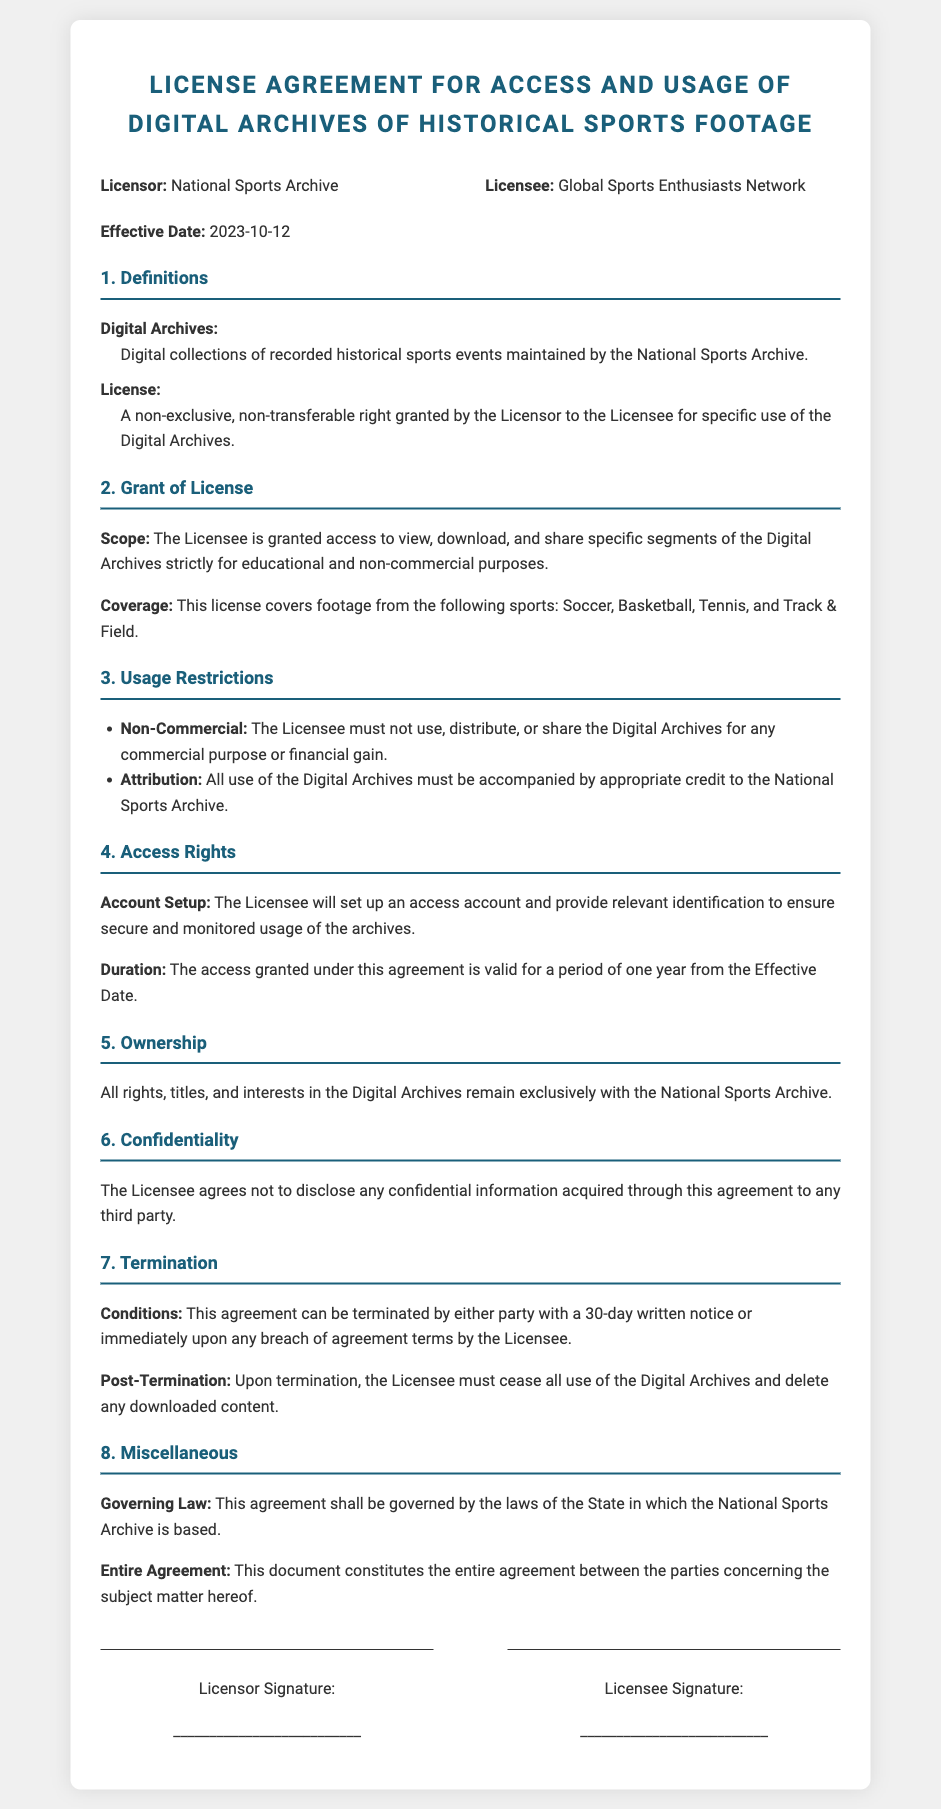What is the name of the Licensor? The Licensor is identified as the National Sports Archive in the document.
Answer: National Sports Archive What is the effective date of the agreement? The effective date is explicitly stated as 2023-10-12 in the document.
Answer: 2023-10-12 What is the duration of the access granted under this agreement? The document specifies that the access is valid for a period of one year from the Effective Date.
Answer: One year Which sports are covered under this license? The document lists the following sports: Soccer, Basketball, Tennis, and Track & Field.
Answer: Soccer, Basketball, Tennis, Track & Field What type of rights does the License grant? The License permits access to the Digital Archives strictly for educational and non-commercial purposes according to the document.
Answer: Non-exclusive, non-transferable What is required for using the Digital Archives? The document states that all use must be accompanied by appropriate credit to the National Sports Archive.
Answer: Attribution What can lead to the termination of the agreement? The agreement can be terminated with a 30-day written notice or immediately upon any breach of agreement terms by the Licensee.
Answer: Breach of agreement terms What must the Licensee do upon termination? The document indicates that the Licensee must cease all use of the Digital Archives and delete any downloaded content upon termination.
Answer: Cease all use and delete downloaded content 